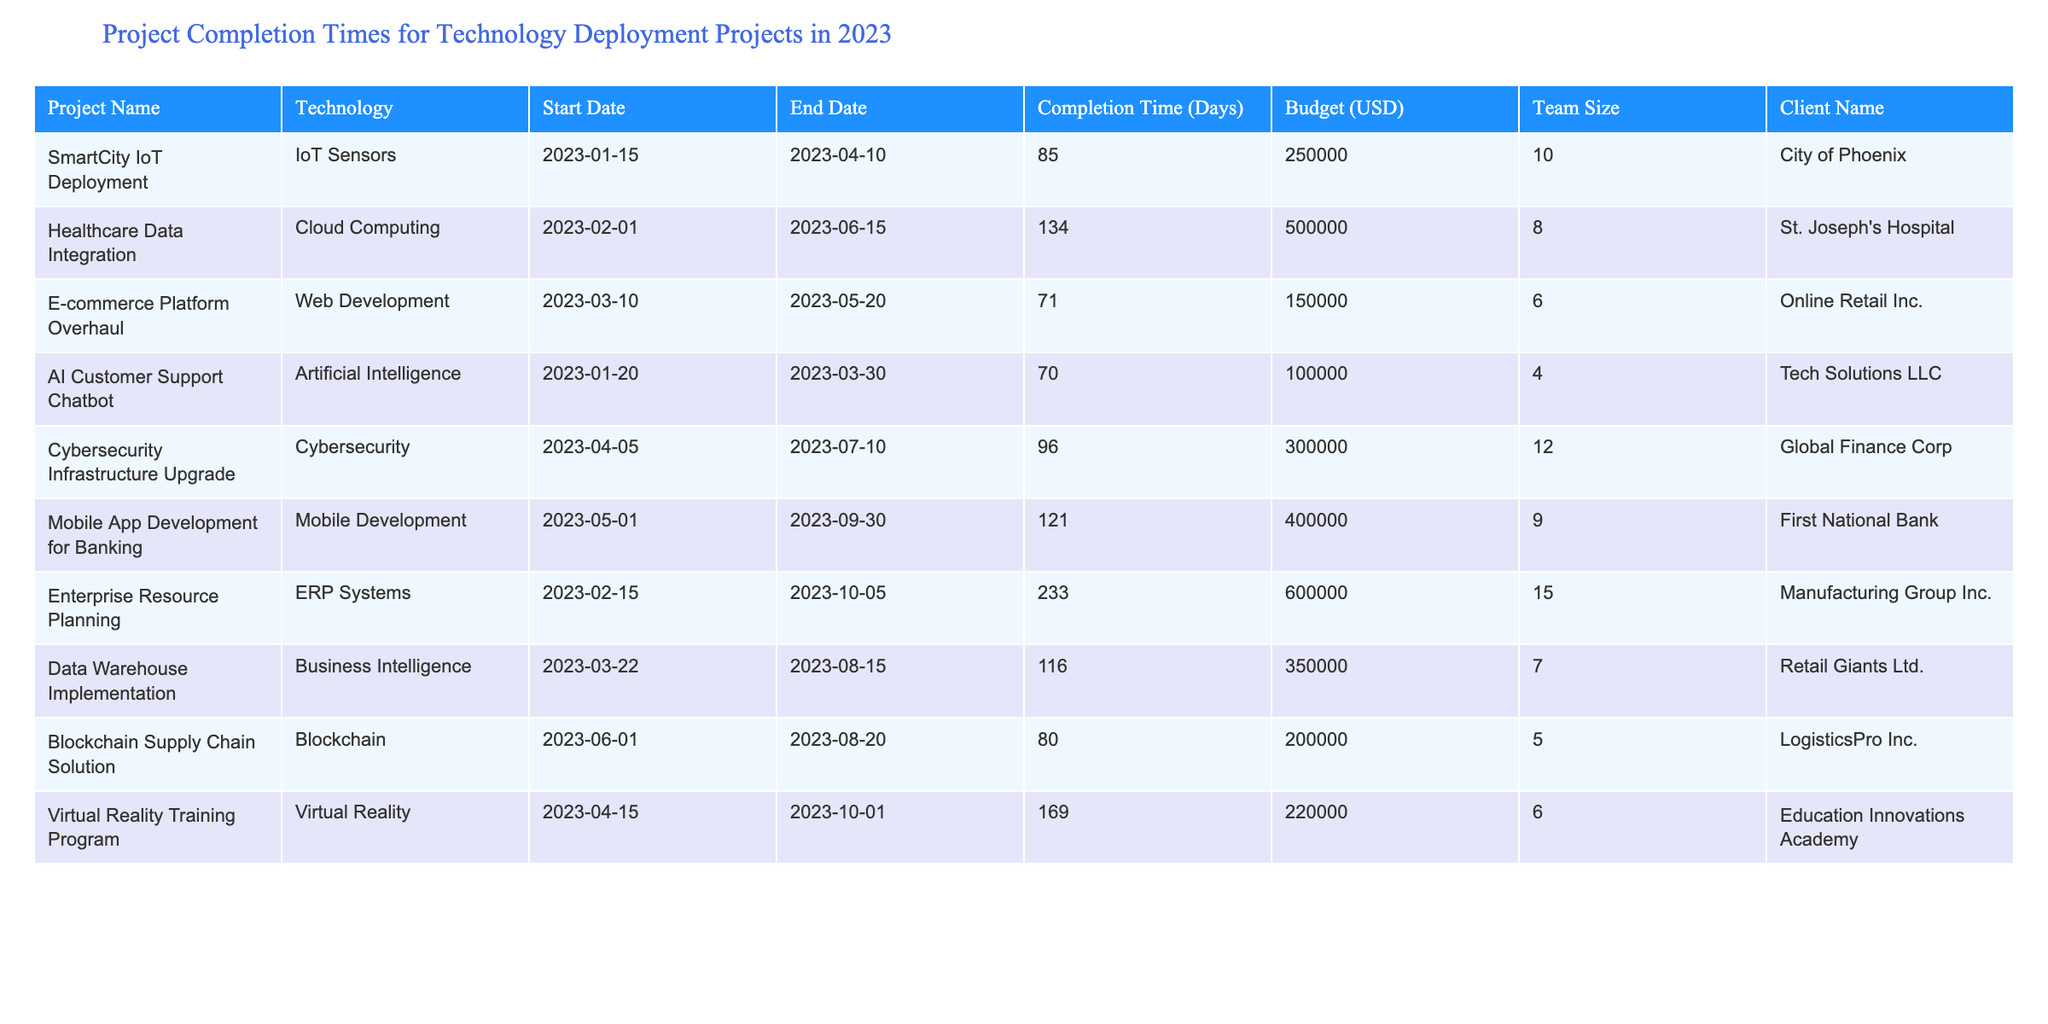What is the project with the longest completion time? The project with the longest completion time can be found by examining the "Completion Time (Days)" column. The highest value in this column is 233 days, corresponding to the "Enterprise Resource Planning" project.
Answer: Enterprise Resource Planning What is the total budget for all projects combined? To find the total budget, I will sum the "Budget (USD)" values: 250000 + 500000 + 150000 + 100000 + 300000 + 400000 + 600000 + 350000 + 200000 + 220000 = 2870000.
Answer: 2870000 Is the project "AI Customer Support Chatbot" completed within 60 days? The "AI Customer Support Chatbot" project has a completion time of 70 days, which is greater than 60 days. Thus, it is not completed within that timeframe.
Answer: No Which technology had the highest average completion time across projects? First, calculate the completion times for each technology and then find the average for each: IoT Sensors (85), Cloud Computing (134), Web Development (71), AI (70), Cybersecurity (96), Mobile Development (121), ERP (233), Business Intelligence (116), Blockchain (80), VR (169). Sum these and divide by the number of projects using each technology to find the average. The average for ERP systems is highest at 233 days.
Answer: ERP Systems Does the client "City of Phoenix" have the smallest team size among all projects? The team size for the project corresponding to the "City of Phoenix" is 10. Now, compare this to all team sizes: 10, 8, 6, 4, 12, 9, 15, 7, 5, 6. The smallest team size is 4 (AI Customer Support Chatbot), which is smaller than the team size for the project by City of Phoenix.
Answer: No 